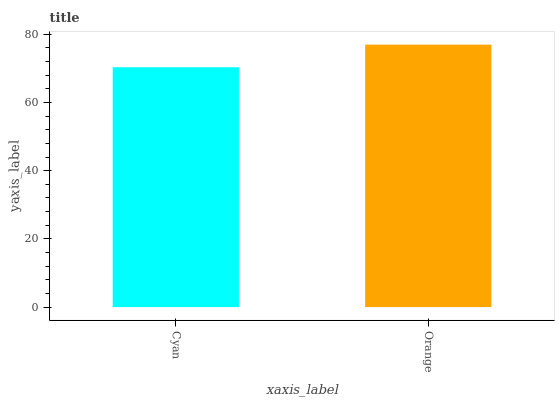Is Cyan the minimum?
Answer yes or no. Yes. Is Orange the maximum?
Answer yes or no. Yes. Is Orange the minimum?
Answer yes or no. No. Is Orange greater than Cyan?
Answer yes or no. Yes. Is Cyan less than Orange?
Answer yes or no. Yes. Is Cyan greater than Orange?
Answer yes or no. No. Is Orange less than Cyan?
Answer yes or no. No. Is Orange the high median?
Answer yes or no. Yes. Is Cyan the low median?
Answer yes or no. Yes. Is Cyan the high median?
Answer yes or no. No. Is Orange the low median?
Answer yes or no. No. 